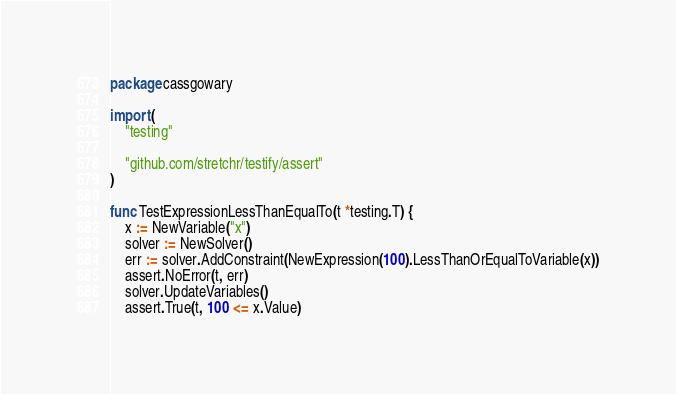Convert code to text. <code><loc_0><loc_0><loc_500><loc_500><_Go_>package cassgowary

import (
	"testing"

	"github.com/stretchr/testify/assert"
)

func TestExpressionLessThanEqualTo(t *testing.T) {
	x := NewVariable("x")
	solver := NewSolver()
	err := solver.AddConstraint(NewExpression(100).LessThanOrEqualToVariable(x))
	assert.NoError(t, err)
	solver.UpdateVariables()
	assert.True(t, 100 <= x.Value)</code> 